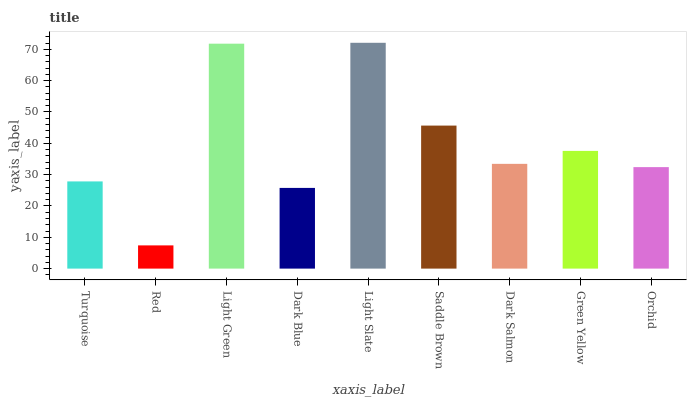Is Red the minimum?
Answer yes or no. Yes. Is Light Slate the maximum?
Answer yes or no. Yes. Is Light Green the minimum?
Answer yes or no. No. Is Light Green the maximum?
Answer yes or no. No. Is Light Green greater than Red?
Answer yes or no. Yes. Is Red less than Light Green?
Answer yes or no. Yes. Is Red greater than Light Green?
Answer yes or no. No. Is Light Green less than Red?
Answer yes or no. No. Is Dark Salmon the high median?
Answer yes or no. Yes. Is Dark Salmon the low median?
Answer yes or no. Yes. Is Red the high median?
Answer yes or no. No. Is Turquoise the low median?
Answer yes or no. No. 